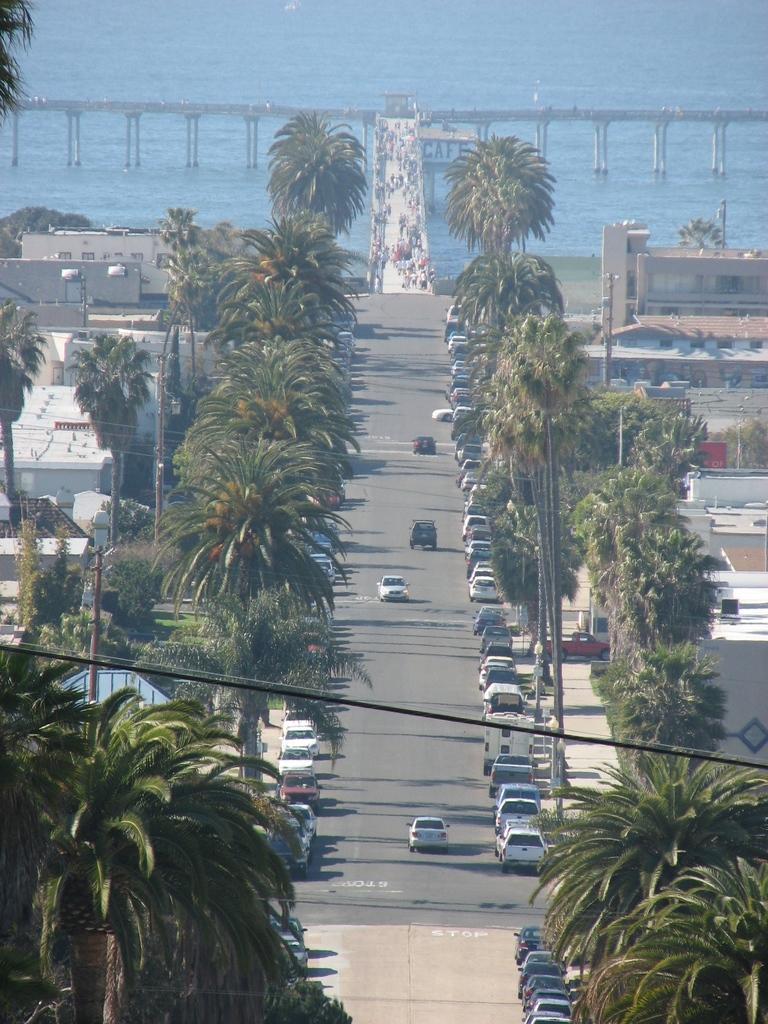Could you give a brief overview of what you see in this image? This picture shows the aerial view. There are two bridges, one sea, so many trees, grass, so many buildings, some cars on the road, some poles, some wires,so many cars are parked in the parking area and some cars parked near the buildings. So many people are on the bridge. 